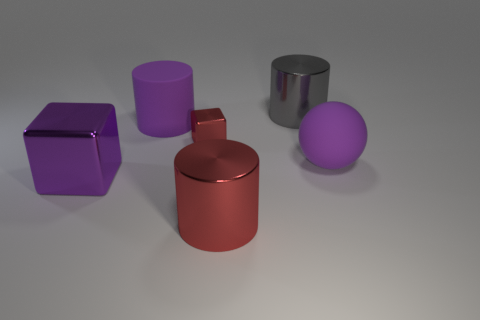Add 2 large cubes. How many objects exist? 8 Subtract all balls. How many objects are left? 5 Add 1 red metal cubes. How many red metal cubes exist? 2 Subtract all red cylinders. How many cylinders are left? 2 Subtract all big metallic cylinders. How many cylinders are left? 1 Subtract 0 brown spheres. How many objects are left? 6 Subtract 1 cubes. How many cubes are left? 1 Subtract all blue spheres. Subtract all purple cylinders. How many spheres are left? 1 Subtract all green cylinders. How many purple cubes are left? 1 Subtract all large gray metal cylinders. Subtract all large cyan rubber things. How many objects are left? 5 